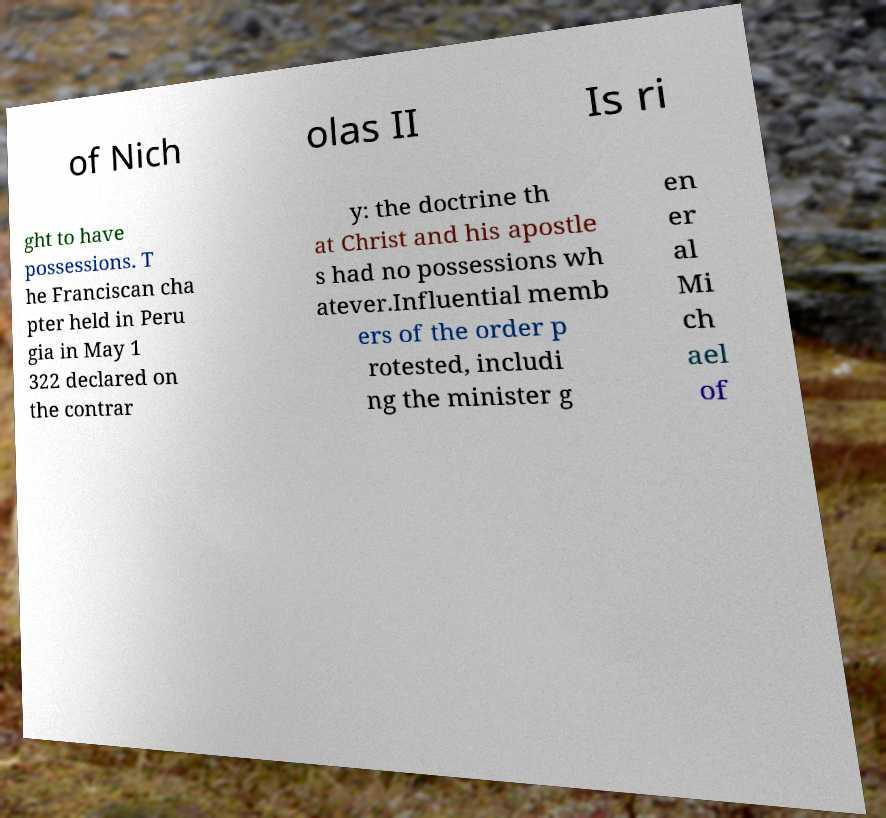Please identify and transcribe the text found in this image. of Nich olas II Is ri ght to have possessions. T he Franciscan cha pter held in Peru gia in May 1 322 declared on the contrar y: the doctrine th at Christ and his apostle s had no possessions wh atever.Influential memb ers of the order p rotested, includi ng the minister g en er al Mi ch ael of 